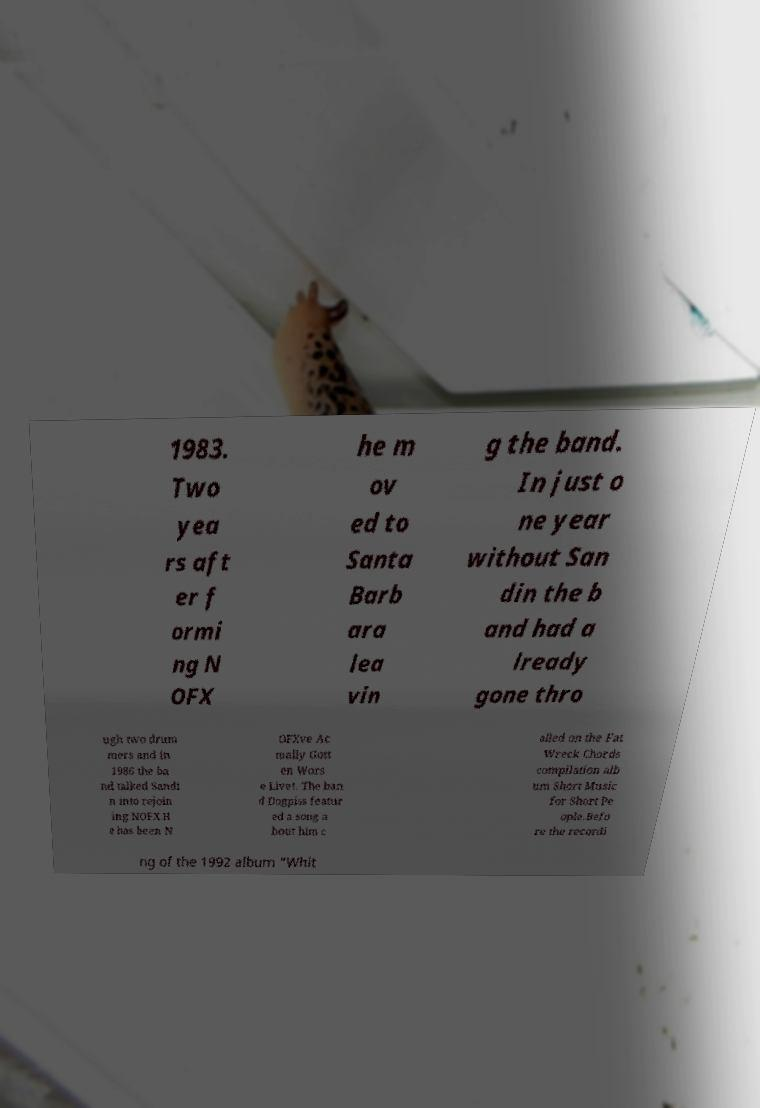Please read and relay the text visible in this image. What does it say? 1983. Two yea rs aft er f ormi ng N OFX he m ov ed to Santa Barb ara lea vin g the band. In just o ne year without San din the b and had a lready gone thro ugh two drum mers and in 1986 the ba nd talked Sandi n into rejoin ing NOFX.H e has been N OFXve Ac tually Gott en Wors e Live!. The ban d Dogpiss featur ed a song a bout him c alled on the Fat Wreck Chords compilation alb um Short Music for Short Pe ople.Befo re the recordi ng of the 1992 album "Whit 